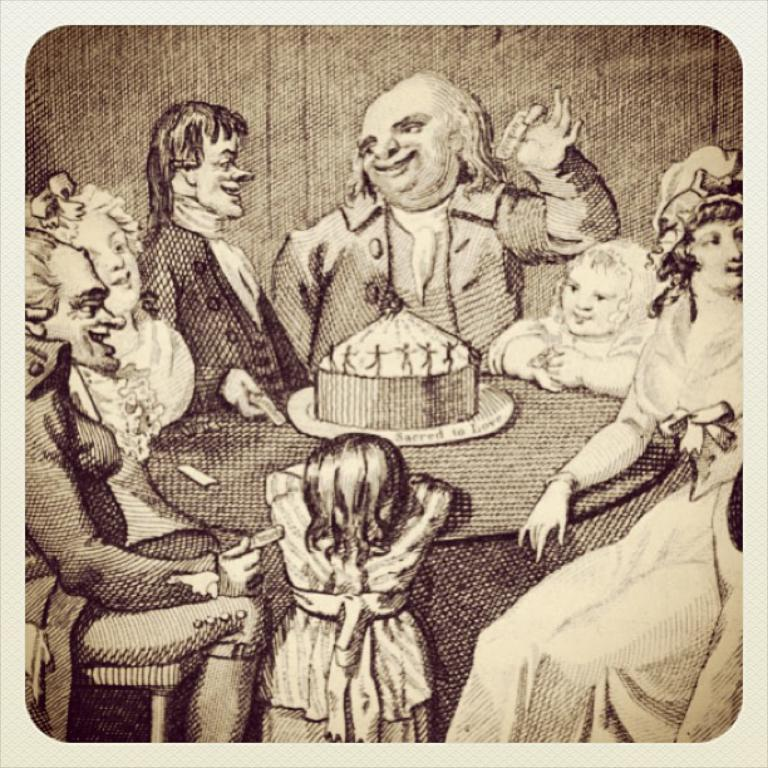What is depicted in the image? The image contains a sketch of people. What are the people in the sketch doing? The people are sitting around a table. What is on the table in the sketch? There is a cake on the table. What type of ray can be seen swimming in the image? There is no ray present in the image; it features a sketch of people sitting around a table with a cake. 